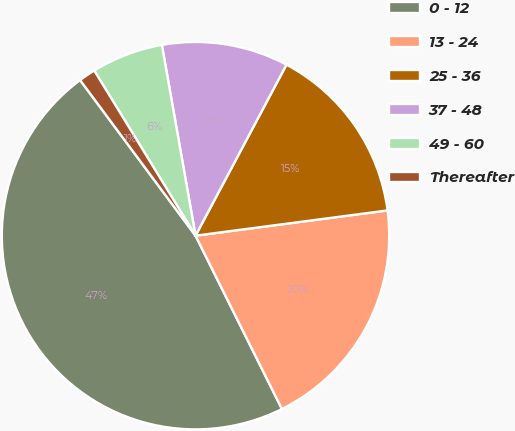<chart> <loc_0><loc_0><loc_500><loc_500><pie_chart><fcel>0 - 12<fcel>13 - 24<fcel>25 - 36<fcel>37 - 48<fcel>49 - 60<fcel>Thereafter<nl><fcel>47.2%<fcel>19.72%<fcel>15.14%<fcel>10.56%<fcel>5.98%<fcel>1.4%<nl></chart> 